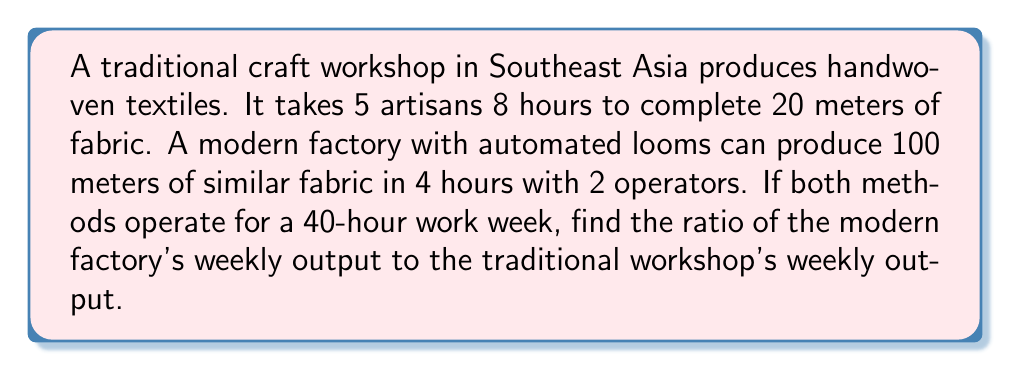Can you answer this question? Let's approach this step-by-step:

1. Calculate the traditional workshop's hourly output:
   $$\text{Traditional output per hour} = \frac{20 \text{ meters}}{8 \text{ hours}} = 2.5 \text{ meters/hour}$$

2. Calculate the traditional workshop's weekly output:
   $$\text{Traditional weekly output} = 2.5 \text{ meters/hour} \times 40 \text{ hours} = 100 \text{ meters}$$

3. Calculate the modern factory's hourly output:
   $$\text{Modern output per hour} = \frac{100 \text{ meters}}{4 \text{ hours}} = 25 \text{ meters/hour}$$

4. Calculate the modern factory's weekly output:
   $$\text{Modern weekly output} = 25 \text{ meters/hour} \times 40 \text{ hours} = 1000 \text{ meters}$$

5. Calculate the ratio of modern to traditional output:
   $$\text{Ratio} = \frac{\text{Modern weekly output}}{\text{Traditional weekly output}} = \frac{1000}{100} = 10:1$$

Thus, the modern factory produces 10 times more fabric than the traditional workshop in a week.
Answer: 10:1 